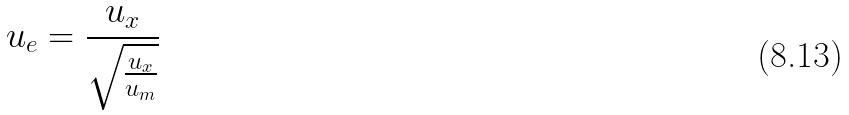<formula> <loc_0><loc_0><loc_500><loc_500>u _ { e } = \frac { u _ { x } } { \sqrt { \frac { u _ { x } } { u _ { m } } } }</formula> 